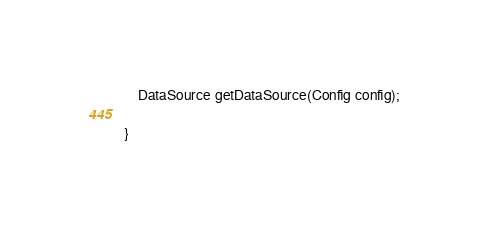Convert code to text. <code><loc_0><loc_0><loc_500><loc_500><_Java_>
    DataSource getDataSource(Config config);

}
</code> 